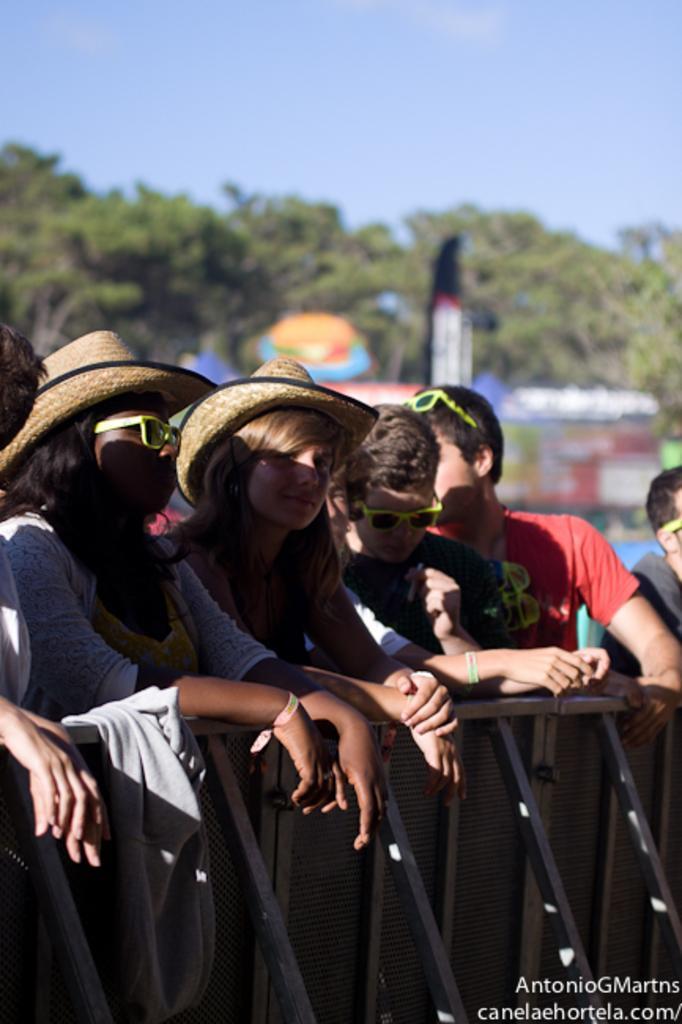Describe this image in one or two sentences. In the center of the image we can see a group of people are standing and some of them are wearing hats, goggles. At the bottom of the image we can see the mesh. In the bottom right corner we can see the text. In the background of the image we can see the trees, train. At the top of the image we can see the sky. 